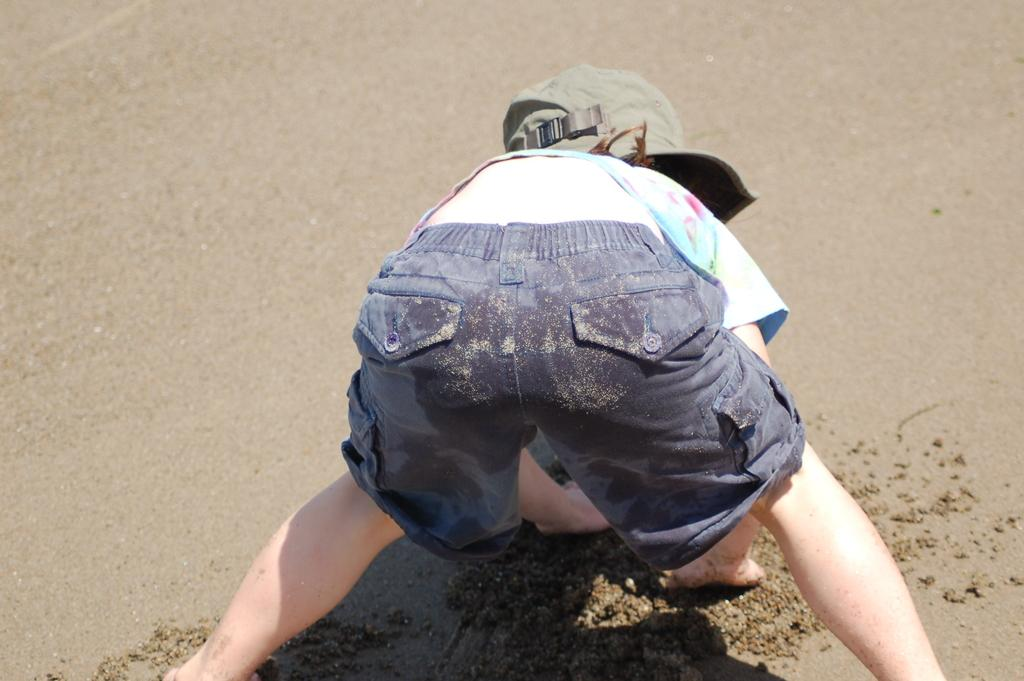What is the main subject of the image? The main subject of the image is a kid. Where is the kid located in the image? The kid is in the middle of the image. What is the kid wearing on their head? The kid is wearing a cap. What type of terrain is visible in the image? There is sand visible in the image. What type of garden can be seen in the background of the image? There is no garden visible in the image; it features a kid in the middle of sand. 